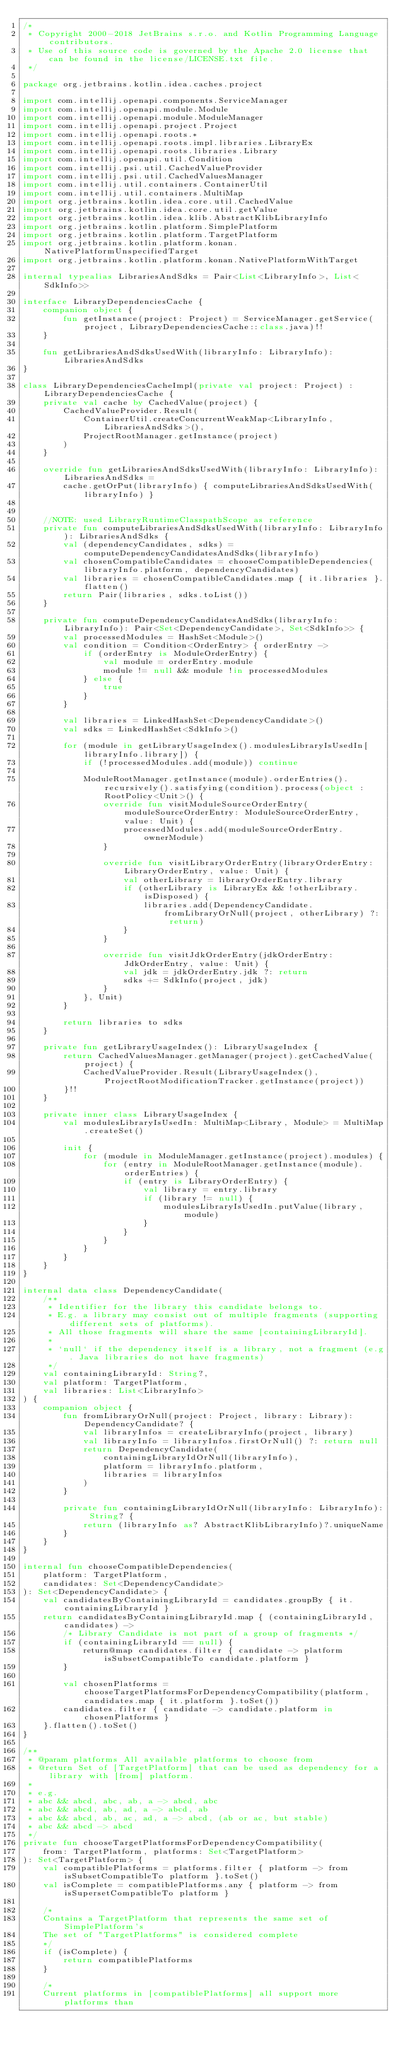Convert code to text. <code><loc_0><loc_0><loc_500><loc_500><_Kotlin_>/*
 * Copyright 2000-2018 JetBrains s.r.o. and Kotlin Programming Language contributors.
 * Use of this source code is governed by the Apache 2.0 license that can be found in the license/LICENSE.txt file.
 */

package org.jetbrains.kotlin.idea.caches.project

import com.intellij.openapi.components.ServiceManager
import com.intellij.openapi.module.Module
import com.intellij.openapi.module.ModuleManager
import com.intellij.openapi.project.Project
import com.intellij.openapi.roots.*
import com.intellij.openapi.roots.impl.libraries.LibraryEx
import com.intellij.openapi.roots.libraries.Library
import com.intellij.openapi.util.Condition
import com.intellij.psi.util.CachedValueProvider
import com.intellij.psi.util.CachedValuesManager
import com.intellij.util.containers.ContainerUtil
import com.intellij.util.containers.MultiMap
import org.jetbrains.kotlin.idea.core.util.CachedValue
import org.jetbrains.kotlin.idea.core.util.getValue
import org.jetbrains.kotlin.idea.klib.AbstractKlibLibraryInfo
import org.jetbrains.kotlin.platform.SimplePlatform
import org.jetbrains.kotlin.platform.TargetPlatform
import org.jetbrains.kotlin.platform.konan.NativePlatformUnspecifiedTarget
import org.jetbrains.kotlin.platform.konan.NativePlatformWithTarget

internal typealias LibrariesAndSdks = Pair<List<LibraryInfo>, List<SdkInfo>>

interface LibraryDependenciesCache {
    companion object {
        fun getInstance(project: Project) = ServiceManager.getService(project, LibraryDependenciesCache::class.java)!!
    }

    fun getLibrariesAndSdksUsedWith(libraryInfo: LibraryInfo): LibrariesAndSdks
}

class LibraryDependenciesCacheImpl(private val project: Project) : LibraryDependenciesCache {
    private val cache by CachedValue(project) {
        CachedValueProvider.Result(
            ContainerUtil.createConcurrentWeakMap<LibraryInfo, LibrariesAndSdks>(),
            ProjectRootManager.getInstance(project)
        )
    }

    override fun getLibrariesAndSdksUsedWith(libraryInfo: LibraryInfo): LibrariesAndSdks =
        cache.getOrPut(libraryInfo) { computeLibrariesAndSdksUsedWith(libraryInfo) }


    //NOTE: used LibraryRuntimeClasspathScope as reference
    private fun computeLibrariesAndSdksUsedWith(libraryInfo: LibraryInfo): LibrariesAndSdks {
        val (dependencyCandidates, sdks) = computeDependencyCandidatesAndSdks(libraryInfo)
        val chosenCompatibleCandidates = chooseCompatibleDependencies(libraryInfo.platform, dependencyCandidates)
        val libraries = chosenCompatibleCandidates.map { it.libraries }.flatten()
        return Pair(libraries, sdks.toList())
    }

    private fun computeDependencyCandidatesAndSdks(libraryInfo: LibraryInfo): Pair<Set<DependencyCandidate>, Set<SdkInfo>> {
        val processedModules = HashSet<Module>()
        val condition = Condition<OrderEntry> { orderEntry ->
            if (orderEntry is ModuleOrderEntry) {
                val module = orderEntry.module
                module != null && module !in processedModules
            } else {
                true
            }
        }

        val libraries = LinkedHashSet<DependencyCandidate>()
        val sdks = LinkedHashSet<SdkInfo>()

        for (module in getLibraryUsageIndex().modulesLibraryIsUsedIn[libraryInfo.library]) {
            if (!processedModules.add(module)) continue

            ModuleRootManager.getInstance(module).orderEntries().recursively().satisfying(condition).process(object : RootPolicy<Unit>() {
                override fun visitModuleSourceOrderEntry(moduleSourceOrderEntry: ModuleSourceOrderEntry, value: Unit) {
                    processedModules.add(moduleSourceOrderEntry.ownerModule)
                }

                override fun visitLibraryOrderEntry(libraryOrderEntry: LibraryOrderEntry, value: Unit) {
                    val otherLibrary = libraryOrderEntry.library
                    if (otherLibrary is LibraryEx && !otherLibrary.isDisposed) {
                        libraries.add(DependencyCandidate.fromLibraryOrNull(project, otherLibrary) ?: return)
                    }
                }

                override fun visitJdkOrderEntry(jdkOrderEntry: JdkOrderEntry, value: Unit) {
                    val jdk = jdkOrderEntry.jdk ?: return
                    sdks += SdkInfo(project, jdk)
                }
            }, Unit)
        }

        return libraries to sdks
    }

    private fun getLibraryUsageIndex(): LibraryUsageIndex {
        return CachedValuesManager.getManager(project).getCachedValue(project) {
            CachedValueProvider.Result(LibraryUsageIndex(), ProjectRootModificationTracker.getInstance(project))
        }!!
    }

    private inner class LibraryUsageIndex {
        val modulesLibraryIsUsedIn: MultiMap<Library, Module> = MultiMap.createSet()

        init {
            for (module in ModuleManager.getInstance(project).modules) {
                for (entry in ModuleRootManager.getInstance(module).orderEntries) {
                    if (entry is LibraryOrderEntry) {
                        val library = entry.library
                        if (library != null) {
                            modulesLibraryIsUsedIn.putValue(library, module)
                        }
                    }
                }
            }
        }
    }
}

internal data class DependencyCandidate(
    /**
     * Identifier for the library this candidate belongs to.
     * E.g. a library may consist out of multiple fragments (supporting different sets of platforms).
     * All those fragments will share the same [containingLibraryId].
     *
     * `null` if the dependency itself is a library, not a fragment (e.g. Java libraries do not have fragments)
     */
    val containingLibraryId: String?,
    val platform: TargetPlatform,
    val libraries: List<LibraryInfo>
) {
    companion object {
        fun fromLibraryOrNull(project: Project, library: Library): DependencyCandidate? {
            val libraryInfos = createLibraryInfo(project, library)
            val libraryInfo = libraryInfos.firstOrNull() ?: return null
            return DependencyCandidate(
                containingLibraryIdOrNull(libraryInfo),
                platform = libraryInfo.platform,
                libraries = libraryInfos
            )
        }

        private fun containingLibraryIdOrNull(libraryInfo: LibraryInfo): String? {
            return (libraryInfo as? AbstractKlibLibraryInfo)?.uniqueName
        }
    }
}

internal fun chooseCompatibleDependencies(
    platform: TargetPlatform,
    candidates: Set<DependencyCandidate>
): Set<DependencyCandidate> {
    val candidatesByContainingLibraryId = candidates.groupBy { it.containingLibraryId }
    return candidatesByContainingLibraryId.map { (containingLibraryId, candidates) ->
        /* Library Candidate is not part of a group of fragments */
        if (containingLibraryId == null) {
            return@map candidates.filter { candidate -> platform isSubsetCompatibleTo candidate.platform }
        }

        val chosenPlatforms = chooseTargetPlatformsForDependencyCompatibility(platform, candidates.map { it.platform }.toSet())
        candidates.filter { candidate -> candidate.platform in chosenPlatforms }
    }.flatten().toSet()
}

/**
 * @param platforms All available platforms to choose from
 * @return Set of [TargetPlatform] that can be used as dependency for a library with [from] platform.
 *
 * e.g.
 * abc && abcd, abc, ab, a -> abcd, abc
 * abc && abcd, ab, ad, a -> abcd, ab
 * abc && abcd, ab, ac, ad, a -> abcd, (ab or ac, but stable)
 * abc && abcd -> abcd
 */
private fun chooseTargetPlatformsForDependencyCompatibility(
    from: TargetPlatform, platforms: Set<TargetPlatform>
): Set<TargetPlatform> {
    val compatiblePlatforms = platforms.filter { platform -> from isSubsetCompatibleTo platform }.toSet()
    val isComplete = compatiblePlatforms.any { platform -> from isSupersetCompatibleTo platform }

    /*
    Contains a TargetPlatform that represents the same set of SimplePlatform's
    The set of "TargetPlatforms" is considered complete
    */
    if (isComplete) {
        return compatiblePlatforms
    }

    /*
    Current platforms in [compatiblePlatforms] all support more platforms than</code> 